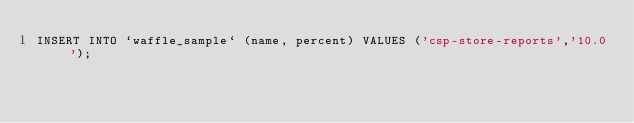Convert code to text. <code><loc_0><loc_0><loc_500><loc_500><_SQL_>INSERT INTO `waffle_sample` (name, percent) VALUES ('csp-store-reports','10.0');
</code> 